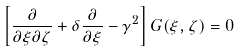<formula> <loc_0><loc_0><loc_500><loc_500>\left [ \frac { \partial } { \partial \xi \partial \zeta } + \delta \frac { \partial } { \partial \xi } - \gamma ^ { 2 } \right ] G ( \xi , \zeta ) = 0 \,</formula> 